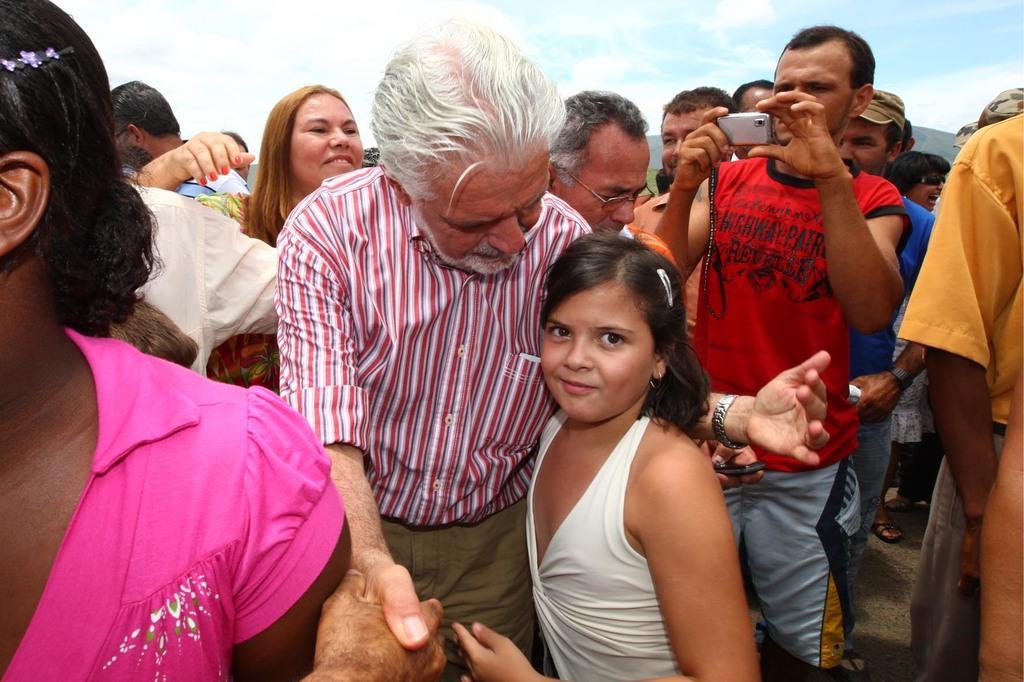How would you summarize this image in a sentence or two? As we can see in the image there are group of people. The man who is standing over here is holding a camera and on the top there is a sky. 